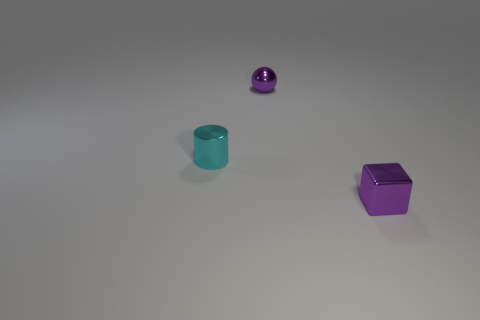Add 1 purple shiny objects. How many objects exist? 4 Subtract all balls. How many objects are left? 2 Subtract all cyan metal objects. Subtract all purple metal things. How many objects are left? 0 Add 3 purple cubes. How many purple cubes are left? 4 Add 2 big gray things. How many big gray things exist? 2 Subtract 0 blue spheres. How many objects are left? 3 